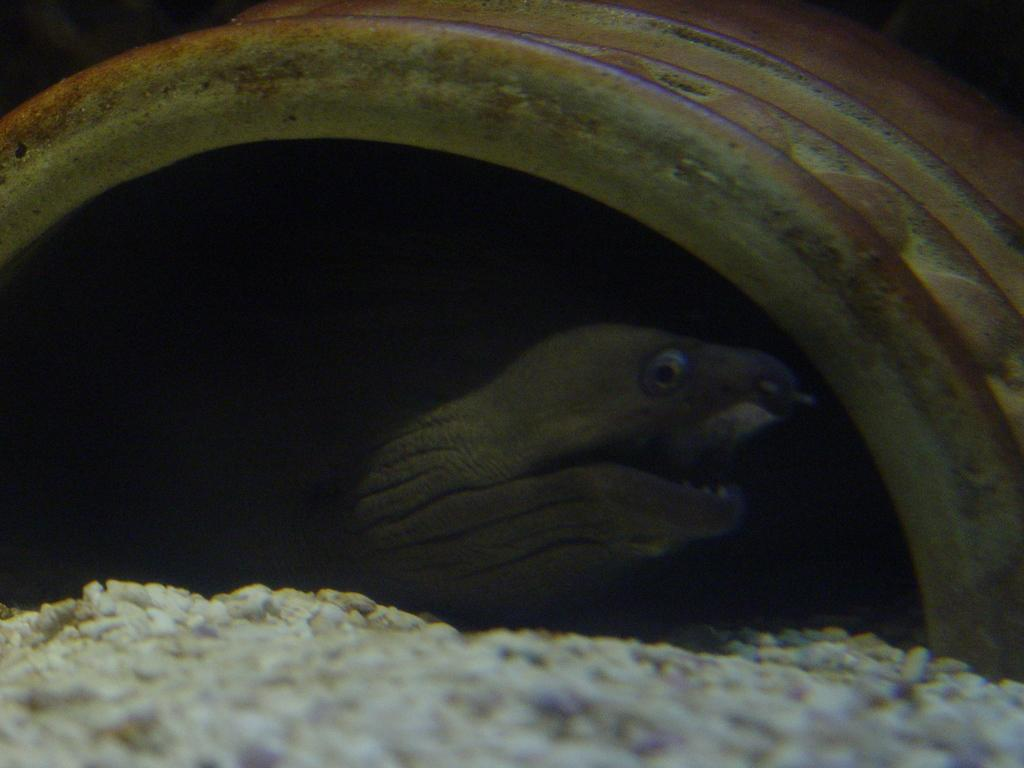What is the main object in the center of the image? There is a tube in the center of the image. What can be found inside the tube? There is a reptile inside the tube. Can you see any oil floating on the lake in the image? There is no lake or oil present in the image; it features a tube with a reptile inside. What type of squirrel can be seen climbing the tree in the image? There is no tree or squirrel present in the image; it only contains a tube with a reptile inside. 